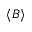<formula> <loc_0><loc_0><loc_500><loc_500>\langle B \rangle</formula> 